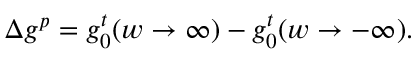<formula> <loc_0><loc_0><loc_500><loc_500>\Delta g ^ { p } = g _ { 0 } ^ { t } ( w \rightarrow \infty ) - g _ { 0 } ^ { t } ( w \rightarrow - \infty ) .</formula> 